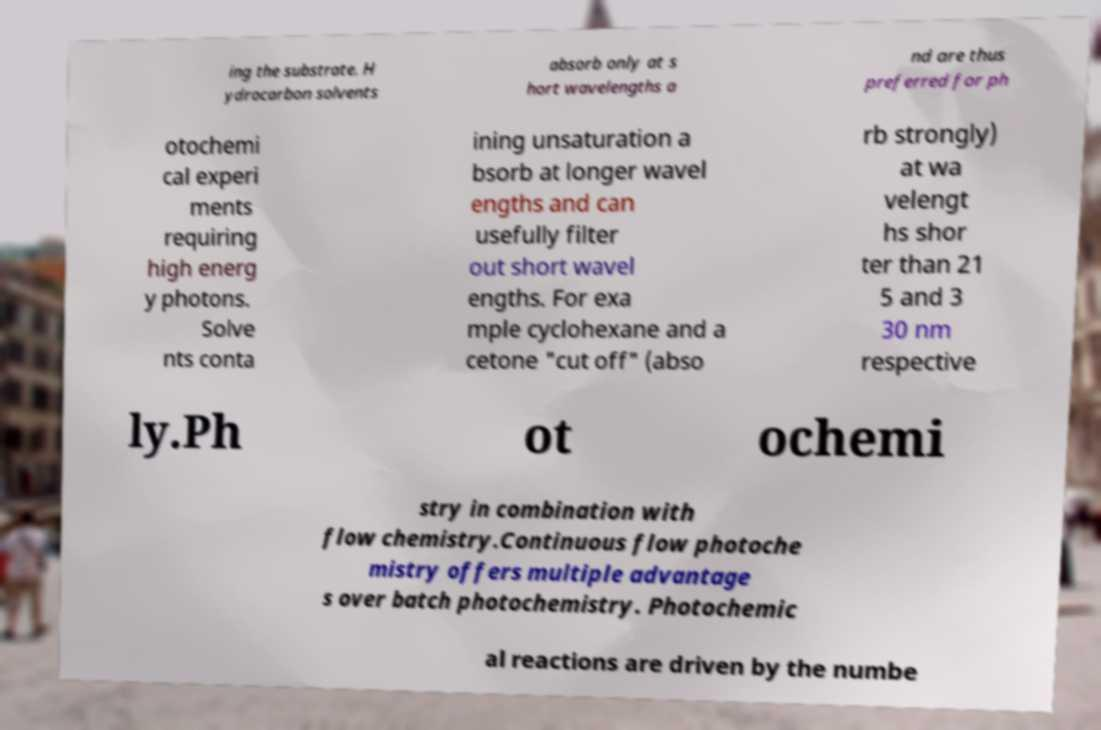Could you assist in decoding the text presented in this image and type it out clearly? ing the substrate. H ydrocarbon solvents absorb only at s hort wavelengths a nd are thus preferred for ph otochemi cal experi ments requiring high energ y photons. Solve nts conta ining unsaturation a bsorb at longer wavel engths and can usefully filter out short wavel engths. For exa mple cyclohexane and a cetone "cut off" (abso rb strongly) at wa velengt hs shor ter than 21 5 and 3 30 nm respective ly.Ph ot ochemi stry in combination with flow chemistry.Continuous flow photoche mistry offers multiple advantage s over batch photochemistry. Photochemic al reactions are driven by the numbe 